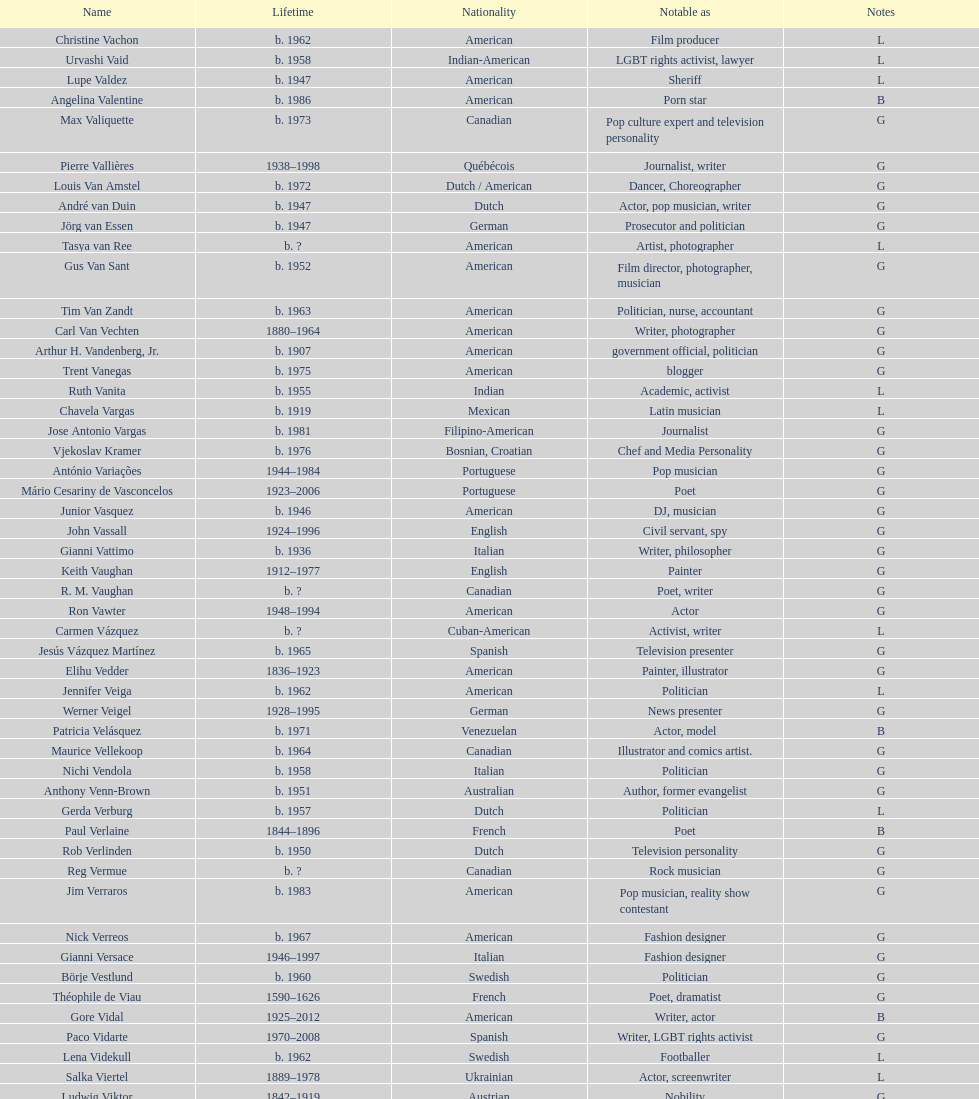Which is the previous name from lupe valdez Urvashi Vaid. Can you give me this table as a dict? {'header': ['Name', 'Lifetime', 'Nationality', 'Notable as', 'Notes'], 'rows': [['Christine Vachon', 'b. 1962', 'American', 'Film producer', 'L'], ['Urvashi Vaid', 'b. 1958', 'Indian-American', 'LGBT rights activist, lawyer', 'L'], ['Lupe Valdez', 'b. 1947', 'American', 'Sheriff', 'L'], ['Angelina Valentine', 'b. 1986', 'American', 'Porn star', 'B'], ['Max Valiquette', 'b. 1973', 'Canadian', 'Pop culture expert and television personality', 'G'], ['Pierre Vallières', '1938–1998', 'Québécois', 'Journalist, writer', 'G'], ['Louis Van Amstel', 'b. 1972', 'Dutch / American', 'Dancer, Choreographer', 'G'], ['André van Duin', 'b. 1947', 'Dutch', 'Actor, pop musician, writer', 'G'], ['Jörg van Essen', 'b. 1947', 'German', 'Prosecutor and politician', 'G'], ['Tasya van Ree', 'b.\xa0?', 'American', 'Artist, photographer', 'L'], ['Gus Van Sant', 'b. 1952', 'American', 'Film director, photographer, musician', 'G'], ['Tim Van Zandt', 'b. 1963', 'American', 'Politician, nurse, accountant', 'G'], ['Carl Van Vechten', '1880–1964', 'American', 'Writer, photographer', 'G'], ['Arthur H. Vandenberg, Jr.', 'b. 1907', 'American', 'government official, politician', 'G'], ['Trent Vanegas', 'b. 1975', 'American', 'blogger', 'G'], ['Ruth Vanita', 'b. 1955', 'Indian', 'Academic, activist', 'L'], ['Chavela Vargas', 'b. 1919', 'Mexican', 'Latin musician', 'L'], ['Jose Antonio Vargas', 'b. 1981', 'Filipino-American', 'Journalist', 'G'], ['Vjekoslav Kramer', 'b. 1976', 'Bosnian, Croatian', 'Chef and Media Personality', 'G'], ['António Variações', '1944–1984', 'Portuguese', 'Pop musician', 'G'], ['Mário Cesariny de Vasconcelos', '1923–2006', 'Portuguese', 'Poet', 'G'], ['Junior Vasquez', 'b. 1946', 'American', 'DJ, musician', 'G'], ['John Vassall', '1924–1996', 'English', 'Civil servant, spy', 'G'], ['Gianni Vattimo', 'b. 1936', 'Italian', 'Writer, philosopher', 'G'], ['Keith Vaughan', '1912–1977', 'English', 'Painter', 'G'], ['R. M. Vaughan', 'b.\xa0?', 'Canadian', 'Poet, writer', 'G'], ['Ron Vawter', '1948–1994', 'American', 'Actor', 'G'], ['Carmen Vázquez', 'b.\xa0?', 'Cuban-American', 'Activist, writer', 'L'], ['Jesús Vázquez Martínez', 'b. 1965', 'Spanish', 'Television presenter', 'G'], ['Elihu Vedder', '1836–1923', 'American', 'Painter, illustrator', 'G'], ['Jennifer Veiga', 'b. 1962', 'American', 'Politician', 'L'], ['Werner Veigel', '1928–1995', 'German', 'News presenter', 'G'], ['Patricia Velásquez', 'b. 1971', 'Venezuelan', 'Actor, model', 'B'], ['Maurice Vellekoop', 'b. 1964', 'Canadian', 'Illustrator and comics artist.', 'G'], ['Nichi Vendola', 'b. 1958', 'Italian', 'Politician', 'G'], ['Anthony Venn-Brown', 'b. 1951', 'Australian', 'Author, former evangelist', 'G'], ['Gerda Verburg', 'b. 1957', 'Dutch', 'Politician', 'L'], ['Paul Verlaine', '1844–1896', 'French', 'Poet', 'B'], ['Rob Verlinden', 'b. 1950', 'Dutch', 'Television personality', 'G'], ['Reg Vermue', 'b.\xa0?', 'Canadian', 'Rock musician', 'G'], ['Jim Verraros', 'b. 1983', 'American', 'Pop musician, reality show contestant', 'G'], ['Nick Verreos', 'b. 1967', 'American', 'Fashion designer', 'G'], ['Gianni Versace', '1946–1997', 'Italian', 'Fashion designer', 'G'], ['Börje Vestlund', 'b. 1960', 'Swedish', 'Politician', 'G'], ['Théophile de Viau', '1590–1626', 'French', 'Poet, dramatist', 'G'], ['Gore Vidal', '1925–2012', 'American', 'Writer, actor', 'B'], ['Paco Vidarte', '1970–2008', 'Spanish', 'Writer, LGBT rights activist', 'G'], ['Lena Videkull', 'b. 1962', 'Swedish', 'Footballer', 'L'], ['Salka Viertel', '1889–1978', 'Ukrainian', 'Actor, screenwriter', 'L'], ['Ludwig Viktor', '1842–1919', 'Austrian', 'Nobility', 'G'], ['Bruce Vilanch', 'b. 1948', 'American', 'Comedy writer, actor', 'G'], ['Tom Villard', '1953–1994', 'American', 'Actor', 'G'], ['José Villarrubia', 'b. 1961', 'American', 'Artist', 'G'], ['Xavier Villaurrutia', '1903–1950', 'Mexican', 'Poet, playwright', 'G'], ["Alain-Philippe Malagnac d'Argens de Villèle", '1950–2000', 'French', 'Aristocrat', 'G'], ['Norah Vincent', 'b.\xa0?', 'American', 'Journalist', 'L'], ['Donald Vining', '1917–1998', 'American', 'Writer', 'G'], ['Luchino Visconti', '1906–1976', 'Italian', 'Filmmaker', 'G'], ['Pavel Vítek', 'b. 1962', 'Czech', 'Pop musician, actor', 'G'], ['Renée Vivien', '1877–1909', 'English', 'Poet', 'L'], ['Claude Vivier', '1948–1983', 'Canadian', '20th century classical composer', 'G'], ['Taylor Vixen', 'b. 1983', 'American', 'Porn star', 'B'], ['Bruce Voeller', '1934–1994', 'American', 'HIV/AIDS researcher', 'G'], ['Paula Vogel', 'b. 1951', 'American', 'Playwright', 'L'], ['Julia Volkova', 'b. 1985', 'Russian', 'Singer', 'B'], ['Jörg van Essen', 'b. 1947', 'German', 'Politician', 'G'], ['Ole von Beust', 'b. 1955', 'German', 'Politician', 'G'], ['Wilhelm von Gloeden', '1856–1931', 'German', 'Photographer', 'G'], ['Rosa von Praunheim', 'b. 1942', 'German', 'Film director', 'G'], ['Kurt von Ruffin', 'b. 1901–1996', 'German', 'Holocaust survivor', 'G'], ['Hella von Sinnen', 'b. 1959', 'German', 'Comedian', 'L'], ['Daniel Vosovic', 'b. 1981', 'American', 'Fashion designer', 'G'], ['Delwin Vriend', 'b. 1966', 'Canadian', 'LGBT rights activist', 'G']]} 